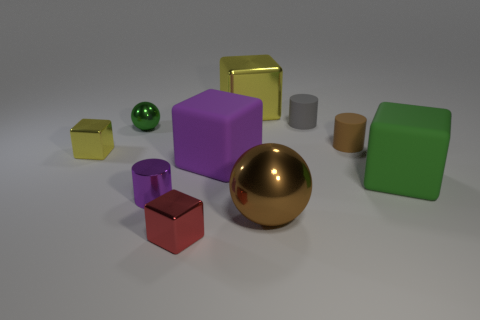How many other objects are the same material as the small ball?
Provide a short and direct response. 5. There is a tiny purple cylinder; are there any small objects in front of it?
Your response must be concise. Yes. There is a brown cylinder; does it have the same size as the yellow object to the right of the green ball?
Keep it short and to the point. No. The shiny sphere that is behind the large rubber thing on the right side of the brown shiny object is what color?
Keep it short and to the point. Green. Is the metal cylinder the same size as the brown rubber cylinder?
Your answer should be compact. Yes. There is a metallic block that is behind the tiny red metal block and in front of the gray thing; what is its color?
Provide a succinct answer. Yellow. What is the size of the gray object?
Your answer should be very brief. Small. Does the tiny cylinder that is to the left of the tiny red thing have the same color as the big sphere?
Ensure brevity in your answer.  No. Is the number of small green metal things in front of the large purple block greater than the number of large objects that are in front of the gray thing?
Your answer should be compact. No. Is the number of matte objects greater than the number of large brown objects?
Provide a succinct answer. Yes. 